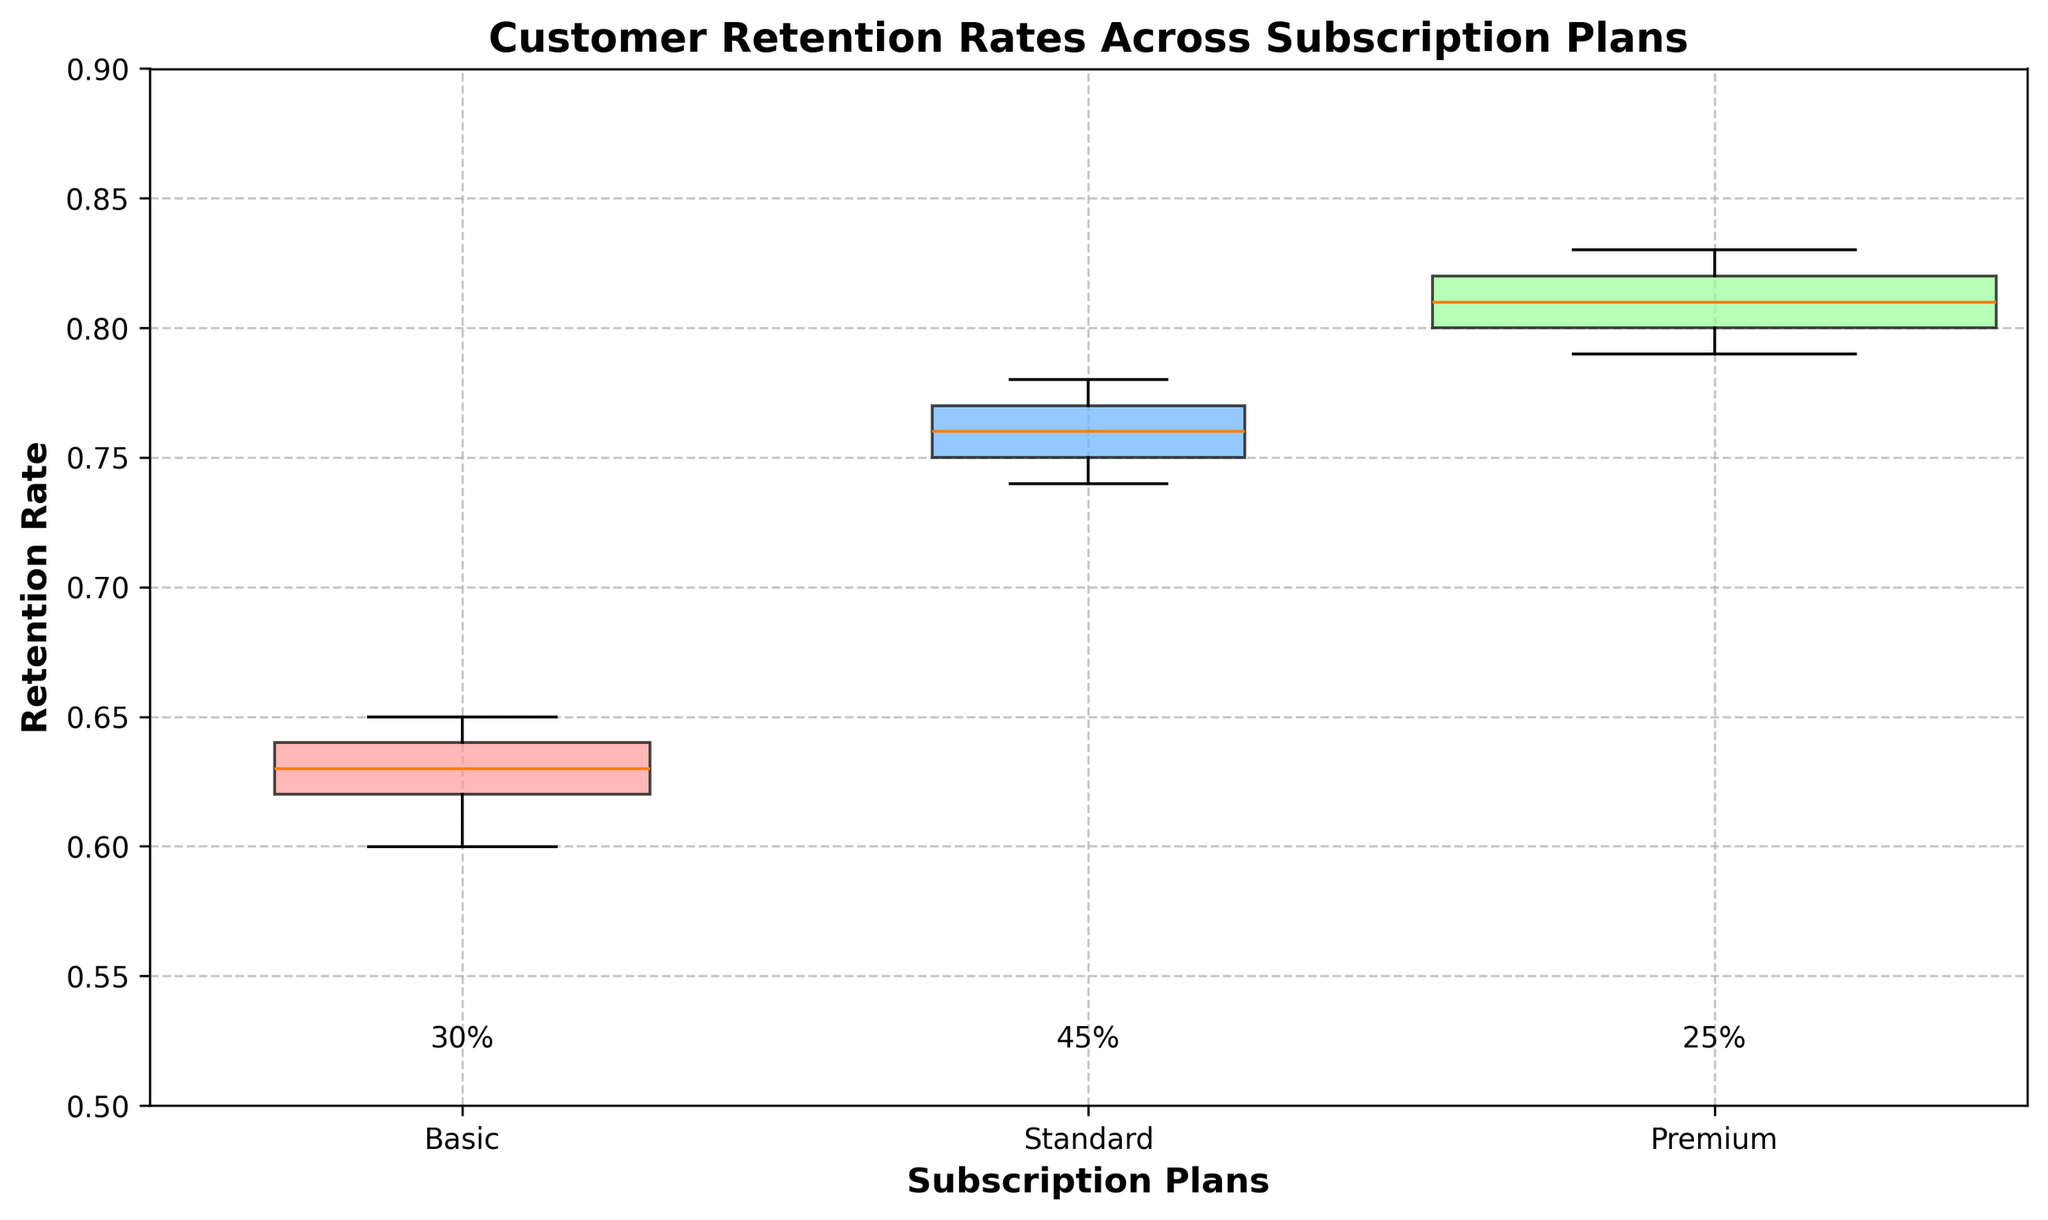What is the title of the plot? The title is displayed at the top of the plot.
Answer: Customer Retention Rates Across Subscription Plans What are the labels of the x-axis and y-axis? The plot clearly labels each axis with respective names.
Answer: Subscription Plans (x-axis), Retention Rate (y-axis) Which subscription plan has the highest median retention rate? The box plot for each plan has a line in the box representing the median. The Premium plan has the highest median retention rate.
Answer: Premium What proportion of the user base is in the Standard subscription plan? The proportion is labeled near the x-axis and the Average Widths of the boxes represent the proportion.
Answer: 45% Which plan has the widest box? Why is it this wide? The width of each box in the Variable Width Box Plot represents the proportion of the user base. Since the Standard plan has the highest proportion, it will have the widest box.
Answer: Standard How does the retention rate variability compare between the Basic and Premium plans? By comparing the height of the boxes (which represents the interquartile range) and the whiskers (which represent the variability), we can see that Premium has less variability than Basic.
Answer: Premium has less variability What's the average retention rate for the Standard plan based on the medians shown in the plot? The medians of the Standard plan’s retention rates in the plot are around 0.75, 0.78, 0.76, and 0.77. The average of these would be (0.75 + 0.78 + 0.76 + 0.77) / 4 = 0.765.
Answer: 0.765 Compare the upper quartiles of the Basic and Standard plans. Which is higher? The upper quartile is the top of the box in each plot. Comparing the boxes' tops, the Standard plan has a higher upper quartile than the Basic plan.
Answer: Standard Does the wider box always mean a higher retention rate? The width of the boxes represents the proportion of the user base, not the retention rate. Higher retention rates are shown by the position on the y-axis, not by the width.
Answer: No What is the approximate range of retention rates for the Premium plan? The range can be determined by the distance from the bottom whisker to the top whisker of the Premium plan's box in the plot.
Answer: Approximately 0.79 to 0.83 